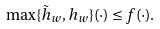Convert formula to latex. <formula><loc_0><loc_0><loc_500><loc_500>\max \{ \tilde { h } _ { w } , h _ { w } \} ( \cdot ) \leq f ( \cdot ) .</formula> 